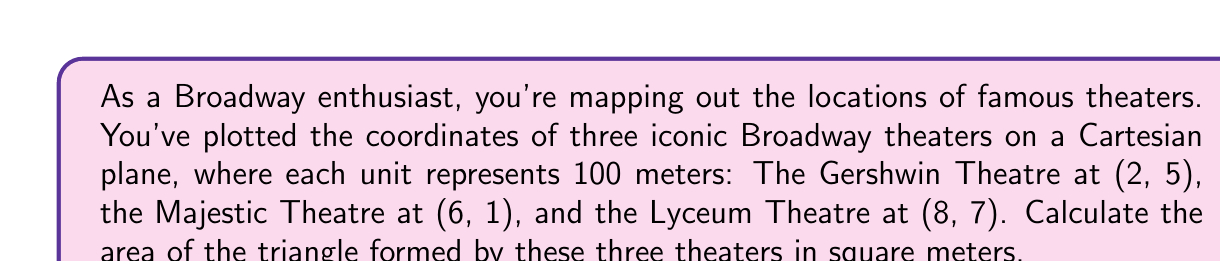Give your solution to this math problem. To solve this problem, we'll use the formula for the area of a triangle given the coordinates of its vertices. Let's follow these steps:

1) The formula for the area of a triangle given the coordinates $(x_1, y_1)$, $(x_2, y_2)$, and $(x_3, y_3)$ is:

   $$A = \frac{1}{2}|x_1(y_2 - y_3) + x_2(y_3 - y_1) + x_3(y_1 - y_2)|$$

2) Let's assign our coordinates:
   - Gershwin Theatre: $(x_1, y_1) = (2, 5)$
   - Majestic Theatre: $(x_2, y_2) = (6, 1)$
   - Lyceum Theatre: $(x_3, y_3) = (8, 7)$

3) Now, let's substitute these into our formula:

   $$A = \frac{1}{2}|2(1 - 7) + 6(7 - 5) + 8(5 - 1)|$$

4) Simplify the expressions inside the parentheses:

   $$A = \frac{1}{2}|2(-6) + 6(2) + 8(4)|$$

5) Multiply:

   $$A = \frac{1}{2}|-12 + 12 + 32|$$

6) Add inside the absolute value signs:

   $$A = \frac{1}{2}|32|$$

7) Calculate:

   $$A = \frac{1}{2} * 32 = 16$$

8) Remember that each unit represents 100 meters, so we need to multiply our result by $100^2 = 10,000$ to get the area in square meters:

   $$A = 16 * 10,000 = 160,000$$

[asy]
unitsize(20);
dot((2,5));
dot((6,1));
dot((8,7));
draw((2,5)--(6,1)--(8,7)--cycle);
label("Gershwin (2,5)", (2,5), NW);
label("Majestic (6,1)", (6,1), SE);
label("Lyceum (8,7)", (8,7), NE);
[/asy]
Answer: The area of the triangle formed by the three Broadway theaters is 160,000 square meters. 